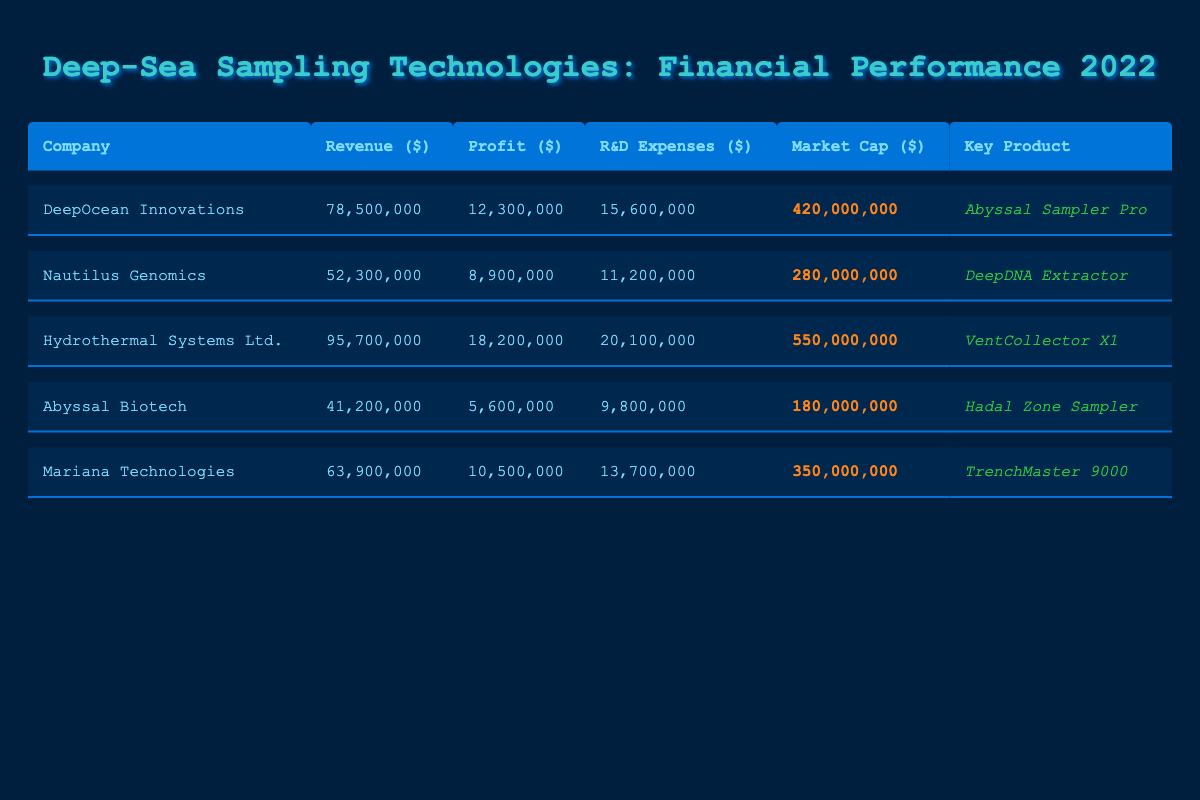What is the revenue of Hydrothermal Systems Ltd.? The revenue for Hydrothermal Systems Ltd. is listed in the table under the Revenue column, which shows a value of 95,700,000.
Answer: 95,700,000 Which company has the highest market capitalization? According to the Market Cap column, Hydrothermal Systems Ltd. has the highest market capitalization at 550,000,000.
Answer: Hydrothermal Systems Ltd What is the profit margin for DeepOcean Innovations? To calculate the profit margin, we use the formula: Profit Margin = (Profit / Revenue) * 100. For DeepOcean Innovations, that’s (12,300,000 / 78,500,000) * 100 = 15.67, which can be rounded to 15.7%.
Answer: 15.7% How much more revenue does Nautilus Genomics make compared to Abyssal Biotech? The revenue of Nautilus Genomics is 52,300,000 and Abyssal Biotech is 41,200,000. To find the difference, we compute 52,300,000 - 41,200,000 = 11,100,000.
Answer: 11,100,000 Is it true that Mariana Technologies spends less than 14 million on R&D expenses? The R&D expenses for Mariana Technologies are listed as 13,700,000, which is indeed less than 14 million. Therefore, the statement is true.
Answer: Yes What is the average revenue for all the companies listed? The revenues for the companies are 78,500,000, 52,300,000, 95,700,000, 41,200,000, and 63,900,000. Adding these amounts gives 331,600,000. To find the average, divide by 5 (the number of companies): 331,600,000 / 5 = 66,320,000.
Answer: 66,320,000 Which company has the lowest profit and what is the amount? By looking through the Profit column, Abyssal Biotech has the lowest profit of 5,600,000 listed.
Answer: Abyssal Biotech, 5,600,000 How do the R&D expenses of Hydrothermal Systems Ltd. compare to the industry average? Hydrothermal Systems Ltd. has R&D expenses of 20,100,000. The industry average for R&D to revenue ratio is 21.3%. To assess this, we check if 20,100,000 is above or below the average, which it is, indicating it is above the average R&D spending.
Answer: Above average What was the key product for DeepOcean Innovations? The key product for DeepOcean Innovations is indicated in the Key Product column as Abyssal Sampler Pro.
Answer: Abyssal Sampler Pro 